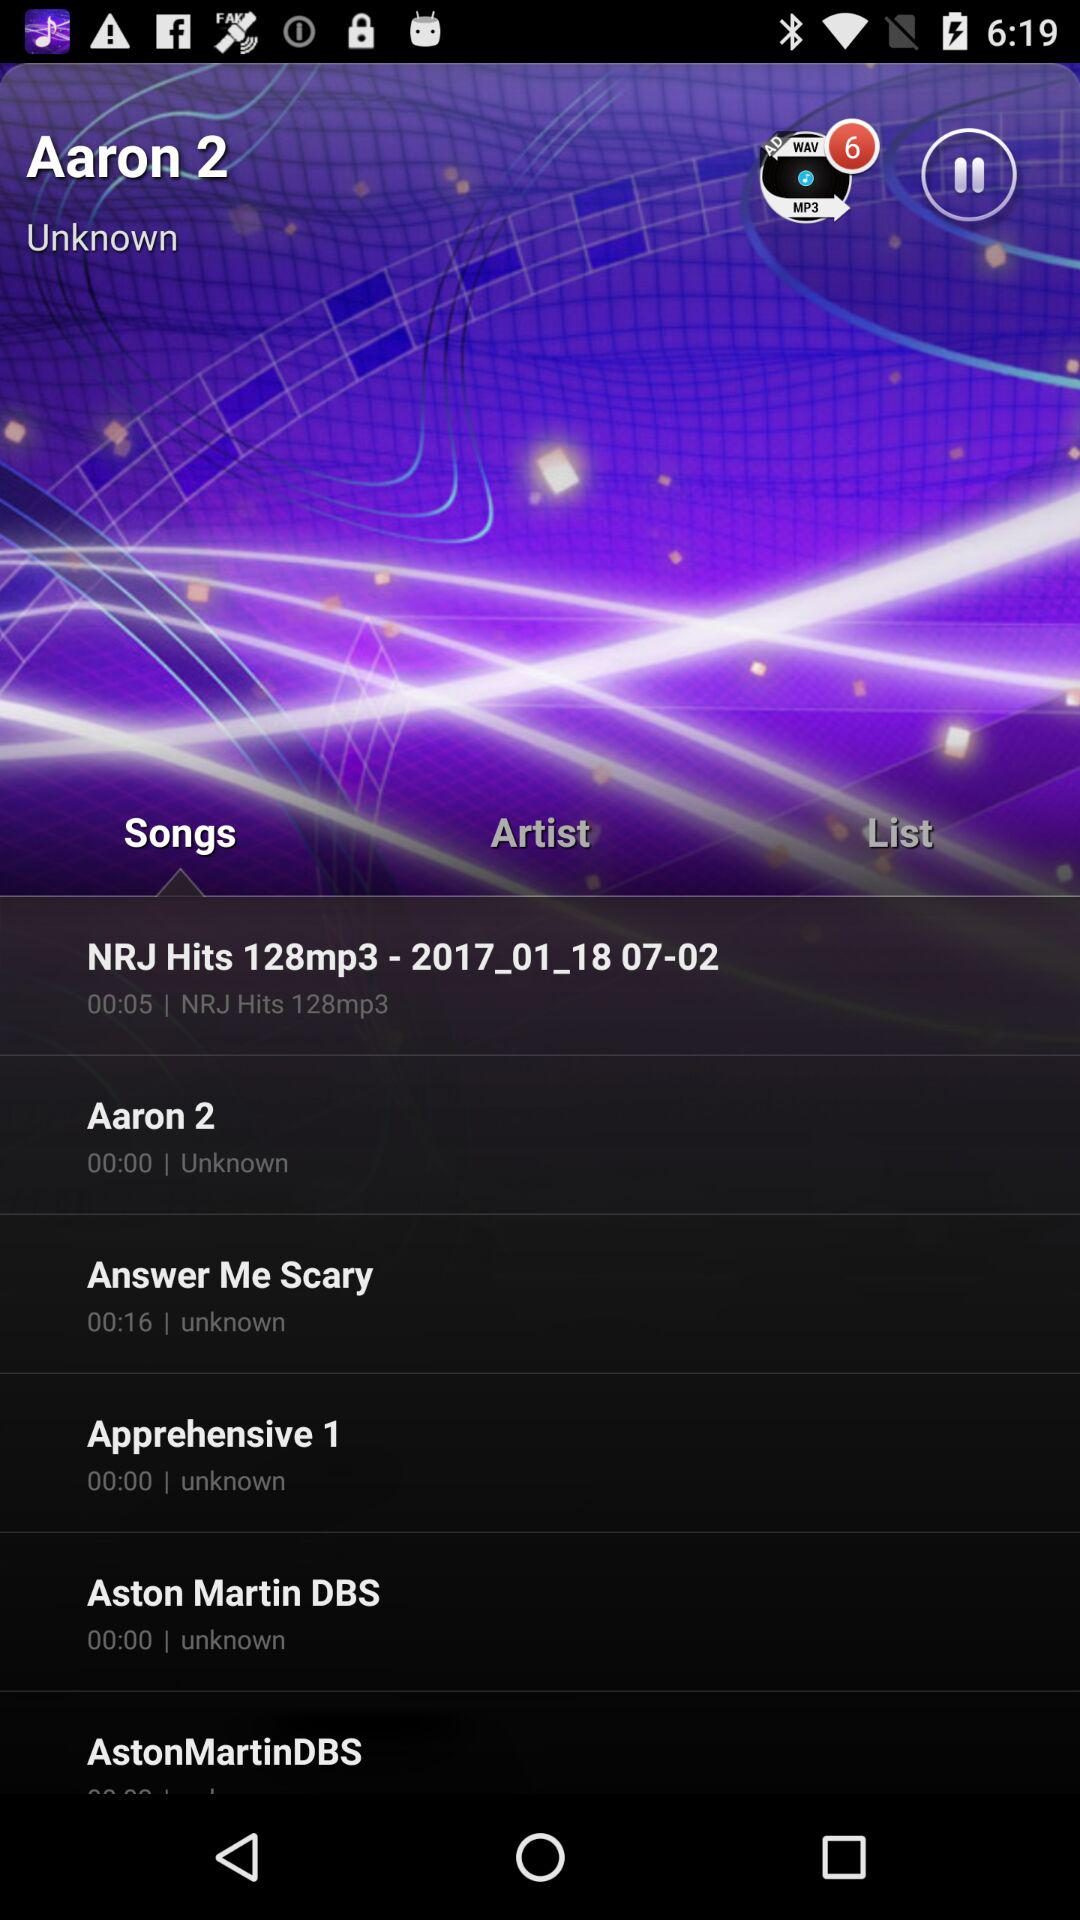What is the duration of the song "Answer Me Scary"? The duration of the song is 16 seconds. 